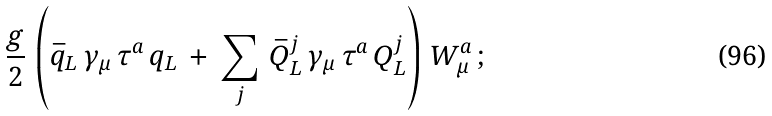<formula> <loc_0><loc_0><loc_500><loc_500>\frac { g } { 2 } \, \left ( \bar { q } _ { L } \, \gamma _ { \mu } \, \tau ^ { a } \, q _ { L } \, + \, \sum _ { j } \, \bar { Q } _ { L } ^ { j } \, \gamma _ { \mu } \, \tau ^ { a } \, Q _ { L } ^ { j } \right ) \, W _ { \mu } ^ { a } \, ;</formula> 